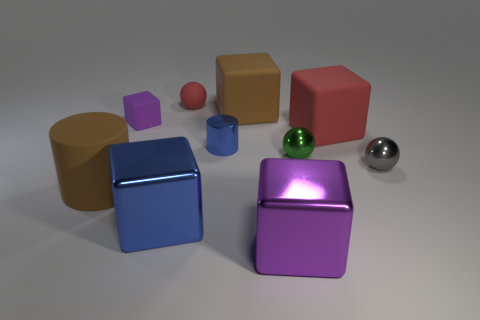Subtract 2 blocks. How many blocks are left? 3 Subtract all green cubes. Subtract all cyan balls. How many cubes are left? 5 Subtract all cylinders. How many objects are left? 8 Subtract 0 cyan cylinders. How many objects are left? 10 Subtract all red matte cubes. Subtract all small purple rubber blocks. How many objects are left? 8 Add 5 small matte blocks. How many small matte blocks are left? 6 Add 1 tiny purple cylinders. How many tiny purple cylinders exist? 1 